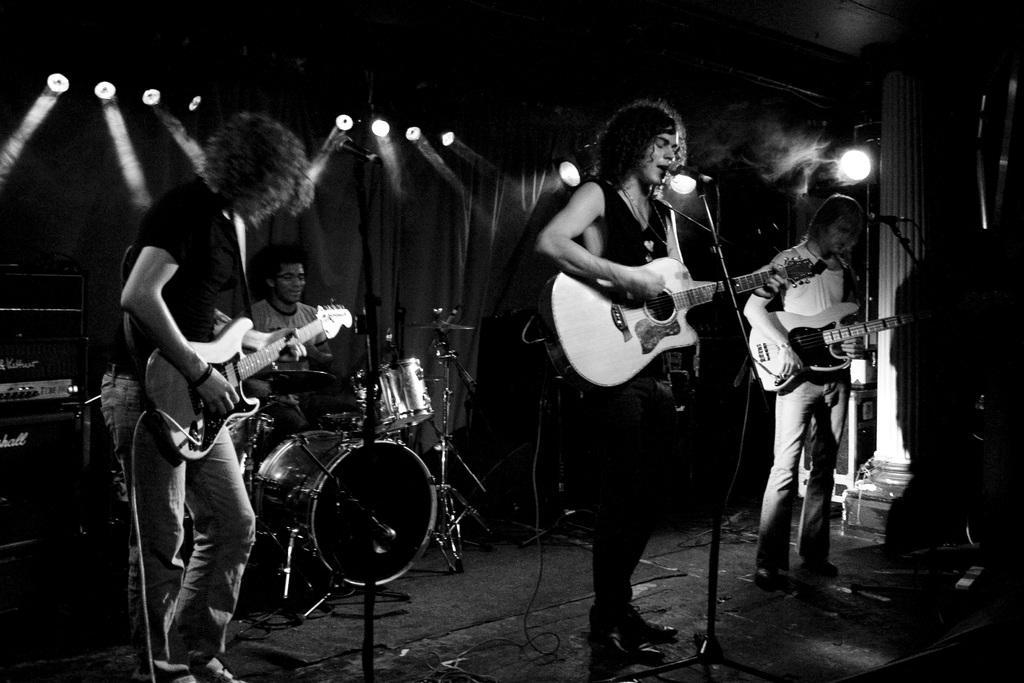In one or two sentences, can you explain what this image depicts? In this image I see 4 men, in which these 3 are holding the guitars and this man is near to the drums and I see that there are mics in front of them. In the background I see lights and the curtain and few equipment over here. 